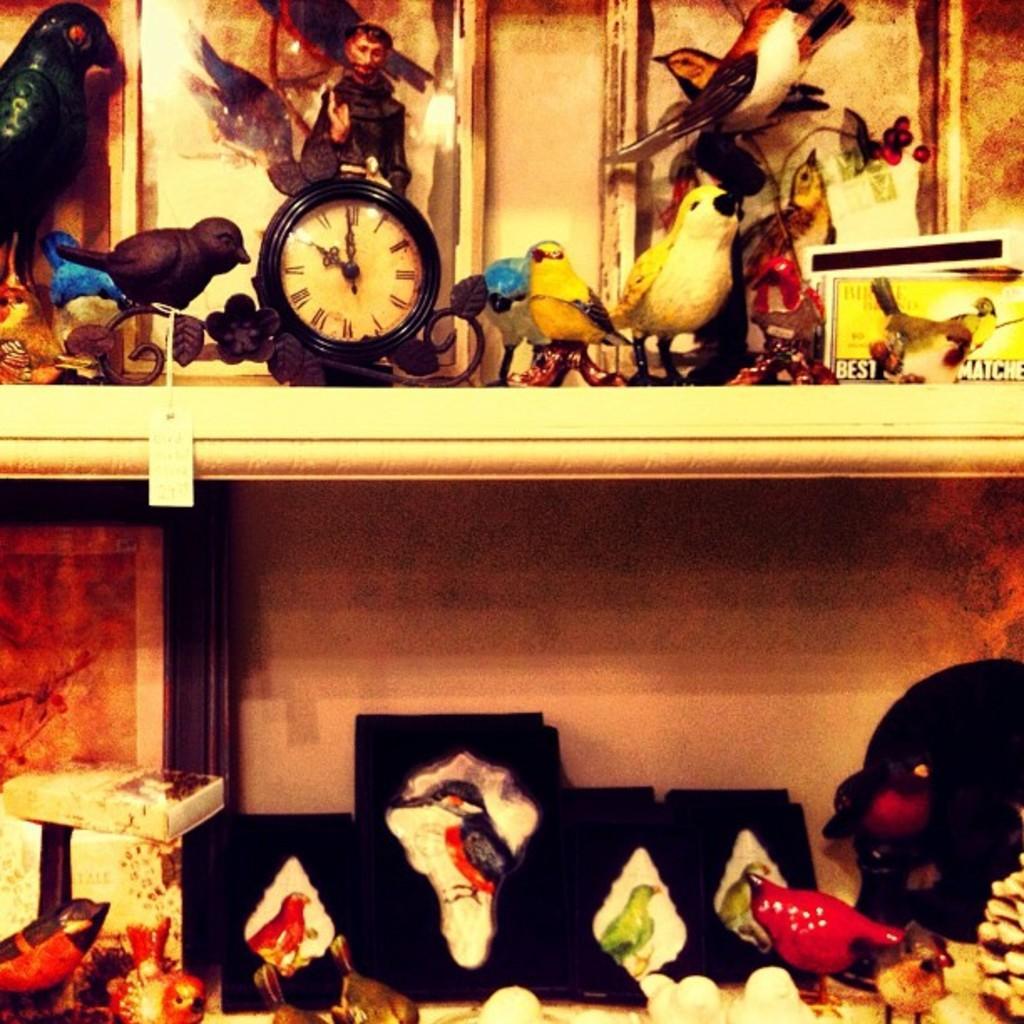In one or two sentences, can you explain what this image depicts? In this image I can see a clock in the shelf. I can see few toys arranged in the shelves. 